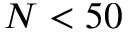<formula> <loc_0><loc_0><loc_500><loc_500>N < 5 0</formula> 